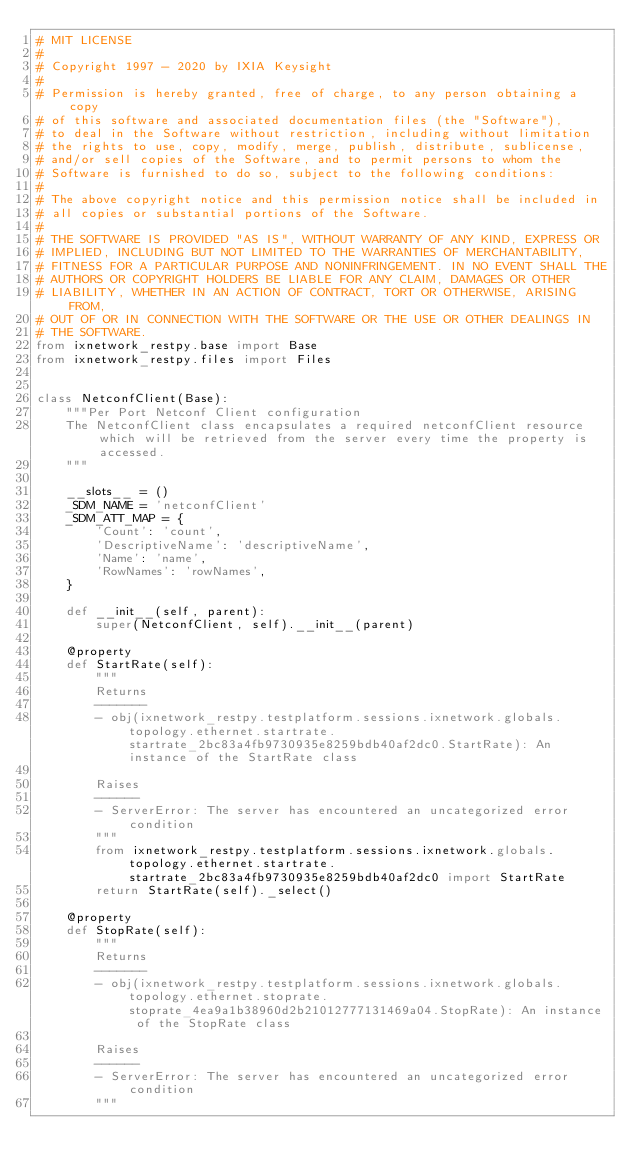<code> <loc_0><loc_0><loc_500><loc_500><_Python_># MIT LICENSE
#
# Copyright 1997 - 2020 by IXIA Keysight
#
# Permission is hereby granted, free of charge, to any person obtaining a copy
# of this software and associated documentation files (the "Software"),
# to deal in the Software without restriction, including without limitation
# the rights to use, copy, modify, merge, publish, distribute, sublicense,
# and/or sell copies of the Software, and to permit persons to whom the
# Software is furnished to do so, subject to the following conditions:
#
# The above copyright notice and this permission notice shall be included in
# all copies or substantial portions of the Software.
#
# THE SOFTWARE IS PROVIDED "AS IS", WITHOUT WARRANTY OF ANY KIND, EXPRESS OR
# IMPLIED, INCLUDING BUT NOT LIMITED TO THE WARRANTIES OF MERCHANTABILITY,
# FITNESS FOR A PARTICULAR PURPOSE AND NONINFRINGEMENT. IN NO EVENT SHALL THE
# AUTHORS OR COPYRIGHT HOLDERS BE LIABLE FOR ANY CLAIM, DAMAGES OR OTHER
# LIABILITY, WHETHER IN AN ACTION OF CONTRACT, TORT OR OTHERWISE, ARISING FROM,
# OUT OF OR IN CONNECTION WITH THE SOFTWARE OR THE USE OR OTHER DEALINGS IN
# THE SOFTWARE. 
from ixnetwork_restpy.base import Base
from ixnetwork_restpy.files import Files


class NetconfClient(Base):
    """Per Port Netconf Client configuration
    The NetconfClient class encapsulates a required netconfClient resource which will be retrieved from the server every time the property is accessed.
    """

    __slots__ = ()
    _SDM_NAME = 'netconfClient'
    _SDM_ATT_MAP = {
        'Count': 'count',
        'DescriptiveName': 'descriptiveName',
        'Name': 'name',
        'RowNames': 'rowNames',
    }

    def __init__(self, parent):
        super(NetconfClient, self).__init__(parent)

    @property
    def StartRate(self):
        """
        Returns
        -------
        - obj(ixnetwork_restpy.testplatform.sessions.ixnetwork.globals.topology.ethernet.startrate.startrate_2bc83a4fb9730935e8259bdb40af2dc0.StartRate): An instance of the StartRate class

        Raises
        ------
        - ServerError: The server has encountered an uncategorized error condition
        """
        from ixnetwork_restpy.testplatform.sessions.ixnetwork.globals.topology.ethernet.startrate.startrate_2bc83a4fb9730935e8259bdb40af2dc0 import StartRate
        return StartRate(self)._select()

    @property
    def StopRate(self):
        """
        Returns
        -------
        - obj(ixnetwork_restpy.testplatform.sessions.ixnetwork.globals.topology.ethernet.stoprate.stoprate_4ea9a1b38960d2b21012777131469a04.StopRate): An instance of the StopRate class

        Raises
        ------
        - ServerError: The server has encountered an uncategorized error condition
        """</code> 